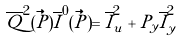Convert formula to latex. <formula><loc_0><loc_0><loc_500><loc_500>\overline { Q } ^ { 2 } ( \vec { P } ) \overline { I } ^ { 0 } ( \vec { P } ) = \overline { I } ^ { 2 } _ { u } + P _ { y } \overline { I } ^ { 2 } _ { y }</formula> 